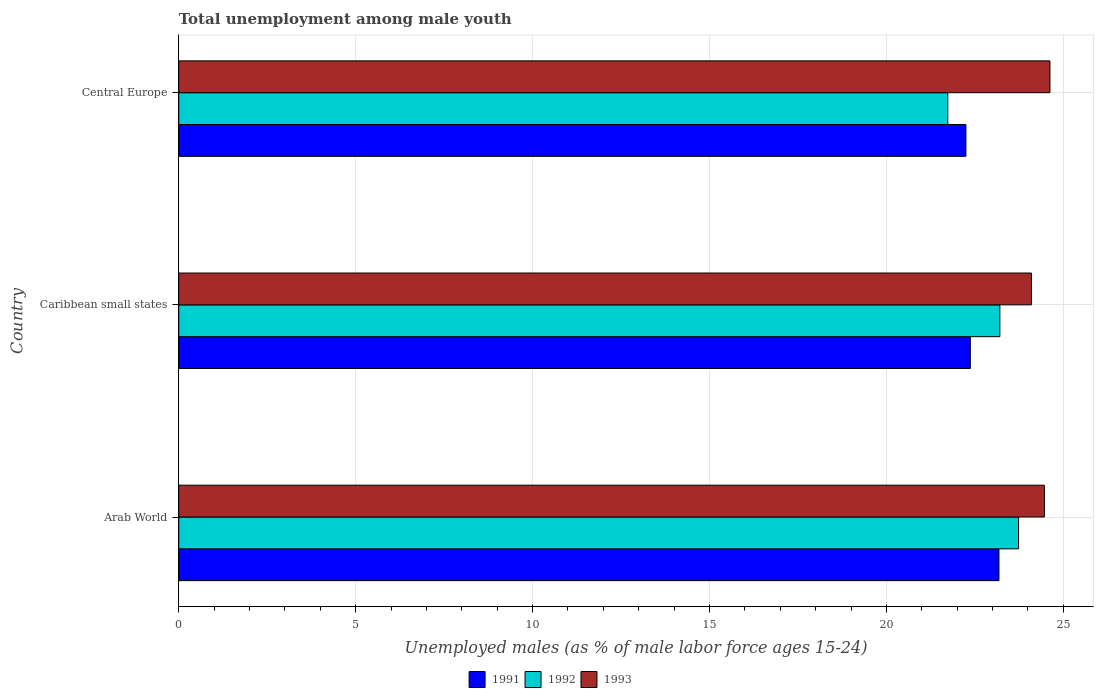Are the number of bars on each tick of the Y-axis equal?
Offer a terse response. Yes. How many bars are there on the 3rd tick from the bottom?
Your answer should be compact. 3. What is the label of the 3rd group of bars from the top?
Offer a terse response. Arab World. In how many cases, is the number of bars for a given country not equal to the number of legend labels?
Your response must be concise. 0. What is the percentage of unemployed males in in 1993 in Caribbean small states?
Ensure brevity in your answer.  24.1. Across all countries, what is the maximum percentage of unemployed males in in 1993?
Your response must be concise. 24.62. Across all countries, what is the minimum percentage of unemployed males in in 1991?
Your answer should be very brief. 22.25. In which country was the percentage of unemployed males in in 1993 maximum?
Offer a very short reply. Central Europe. In which country was the percentage of unemployed males in in 1993 minimum?
Ensure brevity in your answer.  Caribbean small states. What is the total percentage of unemployed males in in 1993 in the graph?
Provide a short and direct response. 73.19. What is the difference between the percentage of unemployed males in in 1991 in Arab World and that in Central Europe?
Make the answer very short. 0.93. What is the difference between the percentage of unemployed males in in 1992 in Caribbean small states and the percentage of unemployed males in in 1991 in Central Europe?
Give a very brief answer. 0.96. What is the average percentage of unemployed males in in 1991 per country?
Make the answer very short. 22.6. What is the difference between the percentage of unemployed males in in 1993 and percentage of unemployed males in in 1991 in Central Europe?
Keep it short and to the point. 2.37. What is the ratio of the percentage of unemployed males in in 1992 in Arab World to that in Caribbean small states?
Keep it short and to the point. 1.02. What is the difference between the highest and the second highest percentage of unemployed males in in 1991?
Offer a terse response. 0.81. What is the difference between the highest and the lowest percentage of unemployed males in in 1991?
Ensure brevity in your answer.  0.93. In how many countries, is the percentage of unemployed males in in 1993 greater than the average percentage of unemployed males in in 1993 taken over all countries?
Your response must be concise. 2. Is it the case that in every country, the sum of the percentage of unemployed males in in 1992 and percentage of unemployed males in in 1993 is greater than the percentage of unemployed males in in 1991?
Your response must be concise. Yes. Are all the bars in the graph horizontal?
Your response must be concise. Yes. What is the difference between two consecutive major ticks on the X-axis?
Make the answer very short. 5. Are the values on the major ticks of X-axis written in scientific E-notation?
Offer a terse response. No. Does the graph contain any zero values?
Keep it short and to the point. No. Where does the legend appear in the graph?
Offer a terse response. Bottom center. How many legend labels are there?
Offer a very short reply. 3. What is the title of the graph?
Your answer should be compact. Total unemployment among male youth. Does "1998" appear as one of the legend labels in the graph?
Offer a terse response. No. What is the label or title of the X-axis?
Keep it short and to the point. Unemployed males (as % of male labor force ages 15-24). What is the Unemployed males (as % of male labor force ages 15-24) in 1991 in Arab World?
Your answer should be very brief. 23.18. What is the Unemployed males (as % of male labor force ages 15-24) of 1992 in Arab World?
Offer a very short reply. 23.74. What is the Unemployed males (as % of male labor force ages 15-24) of 1993 in Arab World?
Your answer should be compact. 24.47. What is the Unemployed males (as % of male labor force ages 15-24) of 1991 in Caribbean small states?
Your answer should be very brief. 22.37. What is the Unemployed males (as % of male labor force ages 15-24) of 1992 in Caribbean small states?
Offer a very short reply. 23.21. What is the Unemployed males (as % of male labor force ages 15-24) of 1993 in Caribbean small states?
Ensure brevity in your answer.  24.1. What is the Unemployed males (as % of male labor force ages 15-24) in 1991 in Central Europe?
Offer a very short reply. 22.25. What is the Unemployed males (as % of male labor force ages 15-24) in 1992 in Central Europe?
Keep it short and to the point. 21.74. What is the Unemployed males (as % of male labor force ages 15-24) of 1993 in Central Europe?
Ensure brevity in your answer.  24.62. Across all countries, what is the maximum Unemployed males (as % of male labor force ages 15-24) in 1991?
Make the answer very short. 23.18. Across all countries, what is the maximum Unemployed males (as % of male labor force ages 15-24) of 1992?
Your answer should be very brief. 23.74. Across all countries, what is the maximum Unemployed males (as % of male labor force ages 15-24) of 1993?
Provide a short and direct response. 24.62. Across all countries, what is the minimum Unemployed males (as % of male labor force ages 15-24) in 1991?
Offer a terse response. 22.25. Across all countries, what is the minimum Unemployed males (as % of male labor force ages 15-24) in 1992?
Keep it short and to the point. 21.74. Across all countries, what is the minimum Unemployed males (as % of male labor force ages 15-24) in 1993?
Keep it short and to the point. 24.1. What is the total Unemployed males (as % of male labor force ages 15-24) in 1991 in the graph?
Make the answer very short. 67.8. What is the total Unemployed males (as % of male labor force ages 15-24) of 1992 in the graph?
Your response must be concise. 68.68. What is the total Unemployed males (as % of male labor force ages 15-24) in 1993 in the graph?
Give a very brief answer. 73.19. What is the difference between the Unemployed males (as % of male labor force ages 15-24) of 1991 in Arab World and that in Caribbean small states?
Offer a very short reply. 0.81. What is the difference between the Unemployed males (as % of male labor force ages 15-24) in 1992 in Arab World and that in Caribbean small states?
Your answer should be very brief. 0.53. What is the difference between the Unemployed males (as % of male labor force ages 15-24) of 1993 in Arab World and that in Caribbean small states?
Keep it short and to the point. 0.37. What is the difference between the Unemployed males (as % of male labor force ages 15-24) of 1991 in Arab World and that in Central Europe?
Your answer should be compact. 0.93. What is the difference between the Unemployed males (as % of male labor force ages 15-24) in 1992 in Arab World and that in Central Europe?
Keep it short and to the point. 2. What is the difference between the Unemployed males (as % of male labor force ages 15-24) in 1993 in Arab World and that in Central Europe?
Offer a very short reply. -0.16. What is the difference between the Unemployed males (as % of male labor force ages 15-24) in 1991 in Caribbean small states and that in Central Europe?
Ensure brevity in your answer.  0.12. What is the difference between the Unemployed males (as % of male labor force ages 15-24) of 1992 in Caribbean small states and that in Central Europe?
Make the answer very short. 1.47. What is the difference between the Unemployed males (as % of male labor force ages 15-24) of 1993 in Caribbean small states and that in Central Europe?
Your answer should be compact. -0.52. What is the difference between the Unemployed males (as % of male labor force ages 15-24) of 1991 in Arab World and the Unemployed males (as % of male labor force ages 15-24) of 1992 in Caribbean small states?
Offer a very short reply. -0.03. What is the difference between the Unemployed males (as % of male labor force ages 15-24) in 1991 in Arab World and the Unemployed males (as % of male labor force ages 15-24) in 1993 in Caribbean small states?
Make the answer very short. -0.92. What is the difference between the Unemployed males (as % of male labor force ages 15-24) of 1992 in Arab World and the Unemployed males (as % of male labor force ages 15-24) of 1993 in Caribbean small states?
Your answer should be very brief. -0.36. What is the difference between the Unemployed males (as % of male labor force ages 15-24) of 1991 in Arab World and the Unemployed males (as % of male labor force ages 15-24) of 1992 in Central Europe?
Ensure brevity in your answer.  1.45. What is the difference between the Unemployed males (as % of male labor force ages 15-24) in 1991 in Arab World and the Unemployed males (as % of male labor force ages 15-24) in 1993 in Central Europe?
Your answer should be compact. -1.44. What is the difference between the Unemployed males (as % of male labor force ages 15-24) in 1992 in Arab World and the Unemployed males (as % of male labor force ages 15-24) in 1993 in Central Europe?
Your answer should be very brief. -0.89. What is the difference between the Unemployed males (as % of male labor force ages 15-24) of 1991 in Caribbean small states and the Unemployed males (as % of male labor force ages 15-24) of 1992 in Central Europe?
Give a very brief answer. 0.64. What is the difference between the Unemployed males (as % of male labor force ages 15-24) in 1991 in Caribbean small states and the Unemployed males (as % of male labor force ages 15-24) in 1993 in Central Europe?
Offer a terse response. -2.25. What is the difference between the Unemployed males (as % of male labor force ages 15-24) of 1992 in Caribbean small states and the Unemployed males (as % of male labor force ages 15-24) of 1993 in Central Europe?
Offer a terse response. -1.42. What is the average Unemployed males (as % of male labor force ages 15-24) in 1991 per country?
Offer a terse response. 22.6. What is the average Unemployed males (as % of male labor force ages 15-24) of 1992 per country?
Offer a terse response. 22.89. What is the average Unemployed males (as % of male labor force ages 15-24) in 1993 per country?
Your answer should be very brief. 24.4. What is the difference between the Unemployed males (as % of male labor force ages 15-24) in 1991 and Unemployed males (as % of male labor force ages 15-24) in 1992 in Arab World?
Make the answer very short. -0.55. What is the difference between the Unemployed males (as % of male labor force ages 15-24) of 1991 and Unemployed males (as % of male labor force ages 15-24) of 1993 in Arab World?
Your response must be concise. -1.28. What is the difference between the Unemployed males (as % of male labor force ages 15-24) in 1992 and Unemployed males (as % of male labor force ages 15-24) in 1993 in Arab World?
Ensure brevity in your answer.  -0.73. What is the difference between the Unemployed males (as % of male labor force ages 15-24) in 1991 and Unemployed males (as % of male labor force ages 15-24) in 1992 in Caribbean small states?
Provide a succinct answer. -0.83. What is the difference between the Unemployed males (as % of male labor force ages 15-24) in 1991 and Unemployed males (as % of male labor force ages 15-24) in 1993 in Caribbean small states?
Offer a terse response. -1.73. What is the difference between the Unemployed males (as % of male labor force ages 15-24) in 1992 and Unemployed males (as % of male labor force ages 15-24) in 1993 in Caribbean small states?
Your answer should be very brief. -0.89. What is the difference between the Unemployed males (as % of male labor force ages 15-24) in 1991 and Unemployed males (as % of male labor force ages 15-24) in 1992 in Central Europe?
Ensure brevity in your answer.  0.51. What is the difference between the Unemployed males (as % of male labor force ages 15-24) in 1991 and Unemployed males (as % of male labor force ages 15-24) in 1993 in Central Europe?
Your answer should be compact. -2.37. What is the difference between the Unemployed males (as % of male labor force ages 15-24) in 1992 and Unemployed males (as % of male labor force ages 15-24) in 1993 in Central Europe?
Your answer should be very brief. -2.89. What is the ratio of the Unemployed males (as % of male labor force ages 15-24) of 1991 in Arab World to that in Caribbean small states?
Provide a short and direct response. 1.04. What is the ratio of the Unemployed males (as % of male labor force ages 15-24) of 1992 in Arab World to that in Caribbean small states?
Your response must be concise. 1.02. What is the ratio of the Unemployed males (as % of male labor force ages 15-24) of 1993 in Arab World to that in Caribbean small states?
Offer a terse response. 1.02. What is the ratio of the Unemployed males (as % of male labor force ages 15-24) in 1991 in Arab World to that in Central Europe?
Ensure brevity in your answer.  1.04. What is the ratio of the Unemployed males (as % of male labor force ages 15-24) in 1992 in Arab World to that in Central Europe?
Offer a terse response. 1.09. What is the ratio of the Unemployed males (as % of male labor force ages 15-24) in 1993 in Arab World to that in Central Europe?
Ensure brevity in your answer.  0.99. What is the ratio of the Unemployed males (as % of male labor force ages 15-24) in 1991 in Caribbean small states to that in Central Europe?
Make the answer very short. 1.01. What is the ratio of the Unemployed males (as % of male labor force ages 15-24) in 1992 in Caribbean small states to that in Central Europe?
Offer a terse response. 1.07. What is the ratio of the Unemployed males (as % of male labor force ages 15-24) of 1993 in Caribbean small states to that in Central Europe?
Keep it short and to the point. 0.98. What is the difference between the highest and the second highest Unemployed males (as % of male labor force ages 15-24) in 1991?
Make the answer very short. 0.81. What is the difference between the highest and the second highest Unemployed males (as % of male labor force ages 15-24) of 1992?
Your answer should be compact. 0.53. What is the difference between the highest and the second highest Unemployed males (as % of male labor force ages 15-24) in 1993?
Make the answer very short. 0.16. What is the difference between the highest and the lowest Unemployed males (as % of male labor force ages 15-24) in 1991?
Ensure brevity in your answer.  0.93. What is the difference between the highest and the lowest Unemployed males (as % of male labor force ages 15-24) of 1992?
Your answer should be very brief. 2. What is the difference between the highest and the lowest Unemployed males (as % of male labor force ages 15-24) in 1993?
Your answer should be compact. 0.52. 